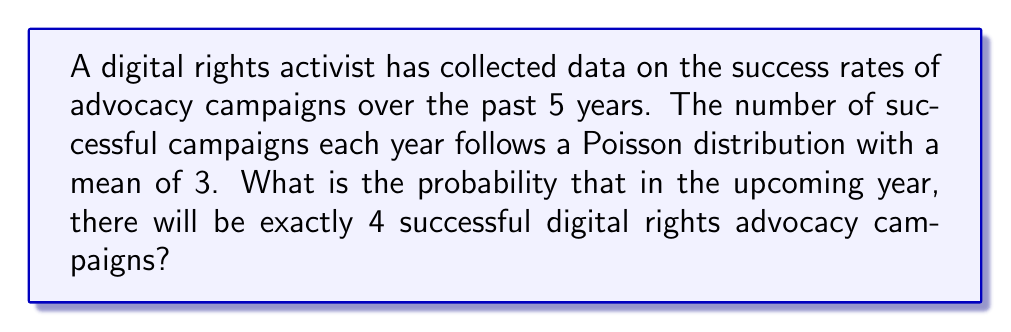Solve this math problem. Let's approach this step-by-step:

1) We are dealing with a Poisson distribution. The probability mass function for a Poisson distribution is:

   $$P(X = k) = \frac{e^{-\lambda} \lambda^k}{k!}$$

   Where:
   - $\lambda$ is the average number of events in the interval
   - $k$ is the number of events we're calculating the probability for
   - $e$ is Euler's number (approximately 2.71828)

2) In this case:
   - $\lambda = 3$ (the mean number of successful campaigns per year)
   - $k = 4$ (we're calculating the probability of exactly 4 successful campaigns)

3) Let's substitute these values into the formula:

   $$P(X = 4) = \frac{e^{-3} 3^4}{4!}$$

4) Now, let's calculate step-by-step:
   
   - $e^{-3} \approx 0.0497871$
   - $3^4 = 81$
   - $4! = 4 \times 3 \times 2 \times 1 = 24$

5) Putting it all together:

   $$P(X = 4) = \frac{0.0497871 \times 81}{24} \approx 0.1680$$

6) Therefore, the probability of exactly 4 successful digital rights advocacy campaigns in the upcoming year is approximately 0.1680 or 16.80%.
Answer: 0.1680 